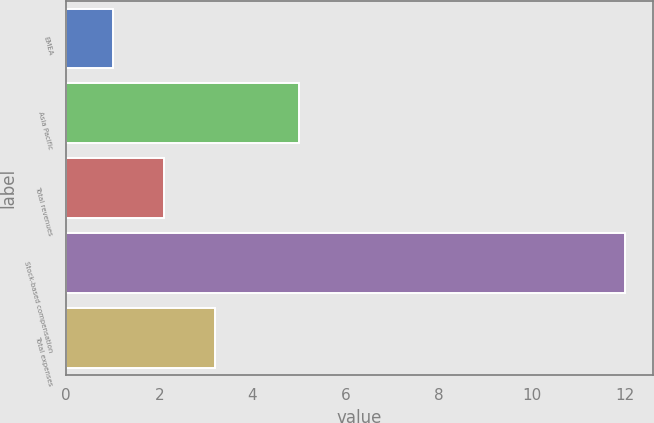Convert chart. <chart><loc_0><loc_0><loc_500><loc_500><bar_chart><fcel>EMEA<fcel>Asia Pacific<fcel>Total revenues<fcel>Stock-based compensation<fcel>Total expenses<nl><fcel>1<fcel>5<fcel>2.1<fcel>12<fcel>3.2<nl></chart> 